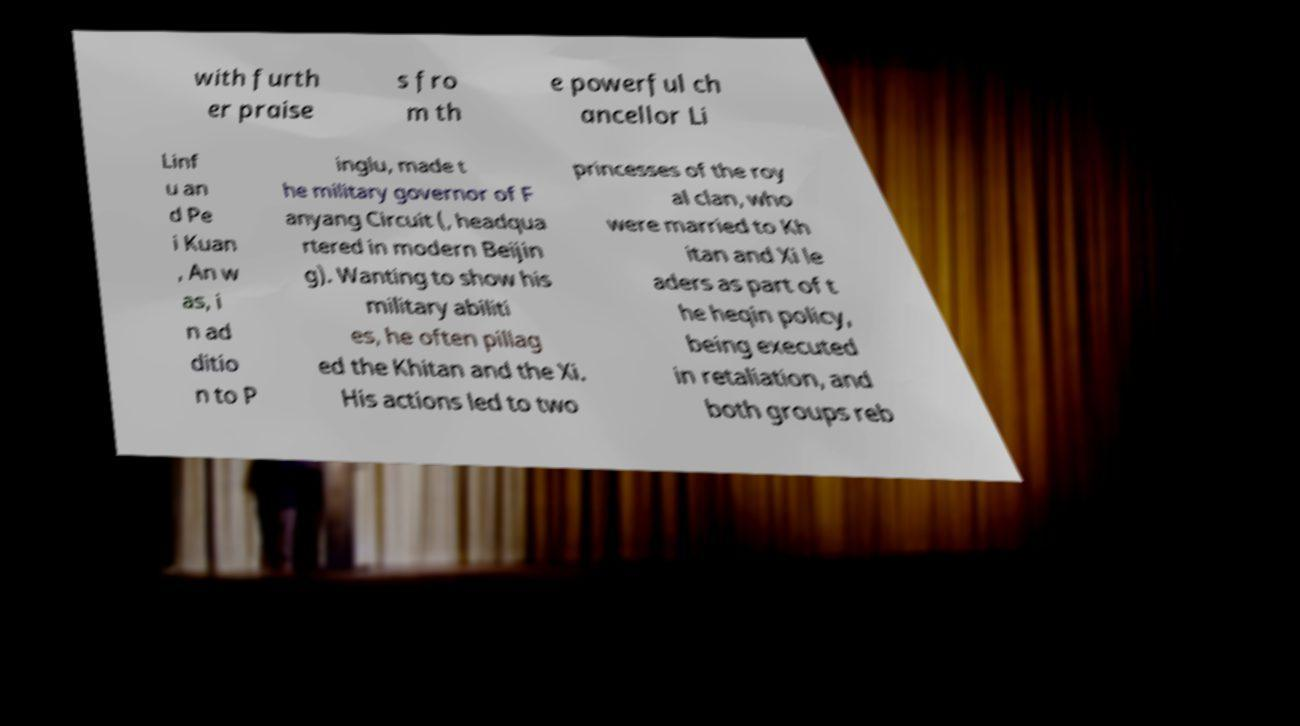What messages or text are displayed in this image? I need them in a readable, typed format. with furth er praise s fro m th e powerful ch ancellor Li Linf u an d Pe i Kuan , An w as, i n ad ditio n to P inglu, made t he military governor of F anyang Circuit (, headqua rtered in modern Beijin g). Wanting to show his military abiliti es, he often pillag ed the Khitan and the Xi. His actions led to two princesses of the roy al clan, who were married to Kh itan and Xi le aders as part of t he heqin policy, being executed in retaliation, and both groups reb 